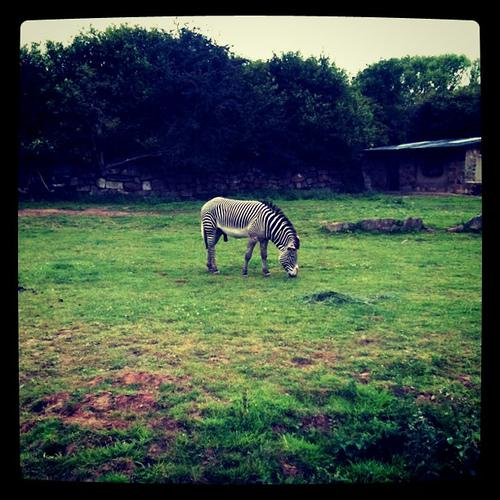Question: what is the zebra doing?
Choices:
A. Drinking.
B. Sleeping.
C. Running.
D. Eating.
Answer with the letter. Answer: D Question: how is the zebra eating?
Choices:
A. Standing up.
B. Laying down.
C. Reaching up.
D. With his mouth.
Answer with the letter. Answer: D Question: who is in the background?
Choices:
A. No one.
B. Men.
C. Women.
D. Children.
Answer with the letter. Answer: A Question: where is the zebra standing?
Choices:
A. In a field.
B. In a zoo.
C. In a lake.
D. On a street.
Answer with the letter. Answer: A Question: what is behind the zebra?
Choices:
A. A tree.
B. A watering hole.
C. A house.
D. A trough.
Answer with the letter. Answer: C 